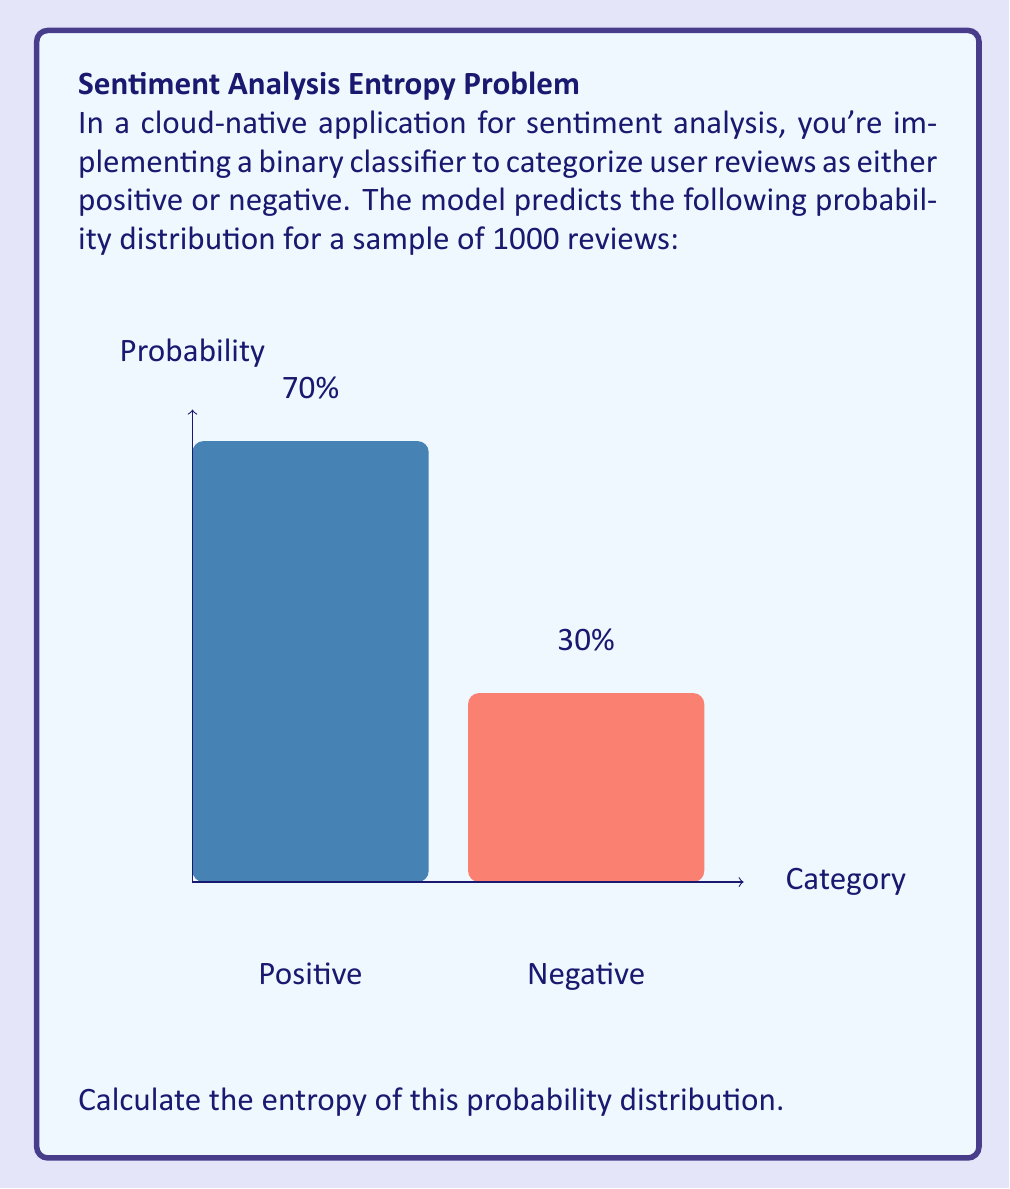Can you solve this math problem? To calculate the entropy of a probability distribution in a binary classification problem, we use the formula:

$$H = -\sum_{i=1}^{n} p_i \log_2(p_i)$$

Where:
- $H$ is the entropy
- $p_i$ is the probability of each class
- $n$ is the number of classes (in this case, 2)

Step 1: Identify the probabilities
$p_1 = 0.7$ (positive)
$p_2 = 0.3$ (negative)

Step 2: Calculate each term in the summation
For $p_1$: $-0.7 \log_2(0.7)$
For $p_2$: $-0.3 \log_2(0.3)$

Step 3: Compute the logarithms
$-0.7 \log_2(0.7) \approx -0.7 \times (-0.5146) \approx 0.3602$
$-0.3 \log_2(0.3) \approx -0.3 \times (-1.7370) \approx 0.5211$

Step 4: Sum the terms
$H = 0.3602 + 0.5211 = 0.8813$

Therefore, the entropy of the probability distribution is approximately 0.8813 bits.
Answer: $0.8813$ bits 